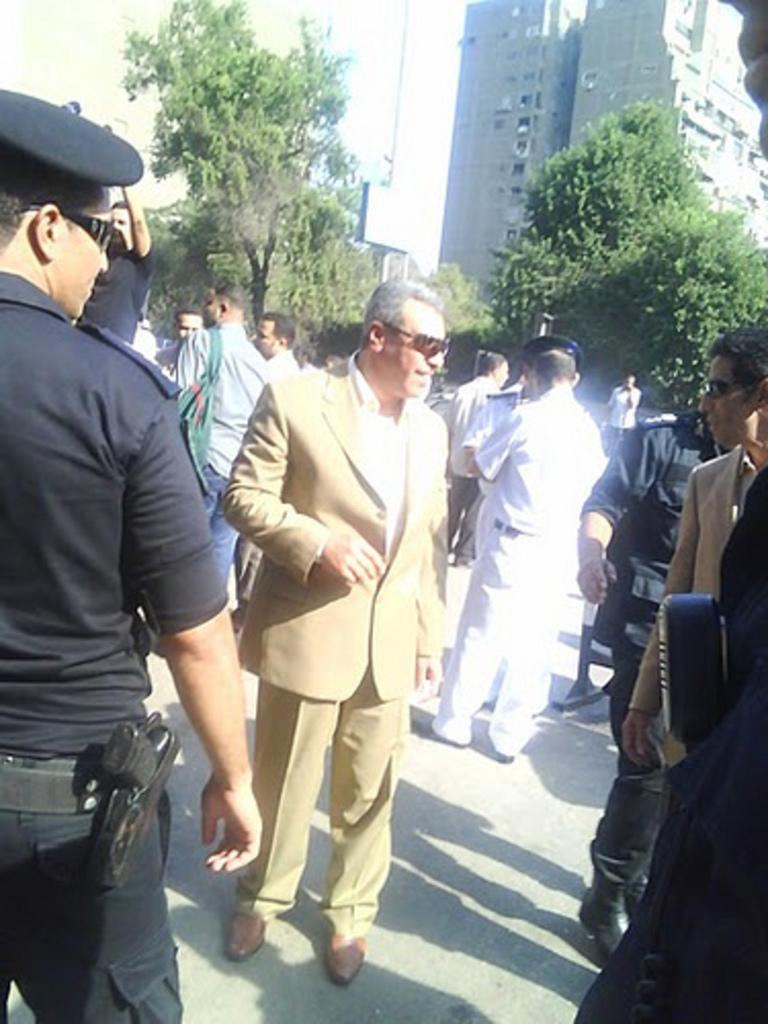In one or two sentences, can you explain what this image depicts? This image consists of many people standing on the road. At the bottom, there is a road. In the background, there are trees along with buildings. At the top, there is sky. 